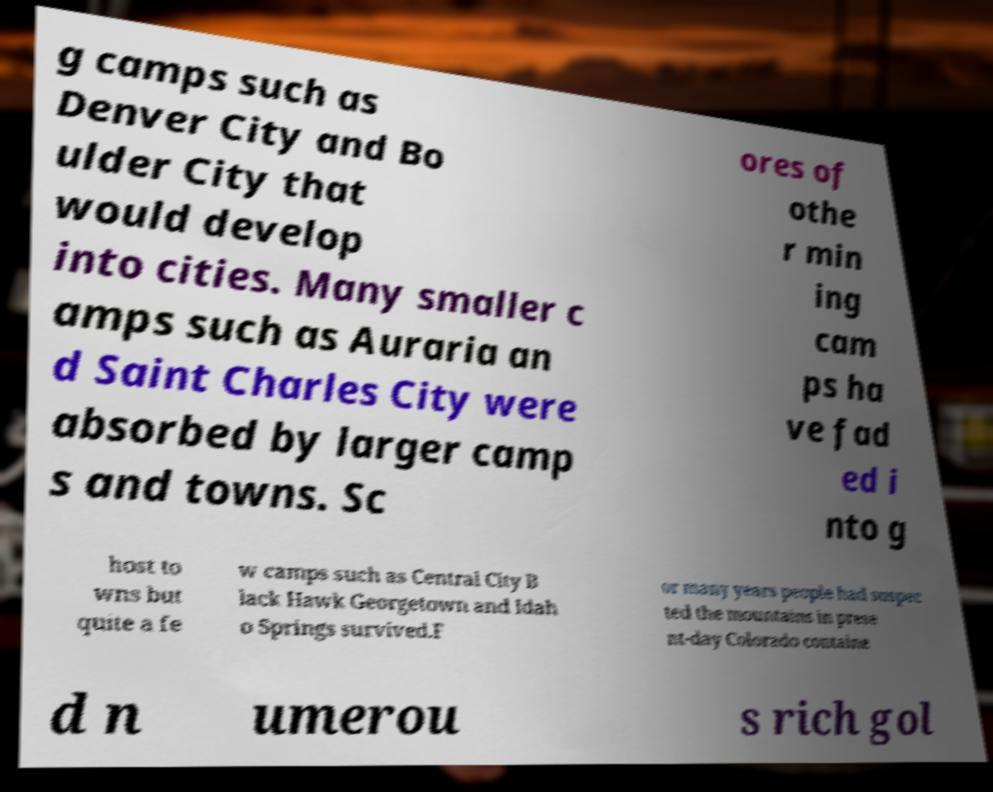Please read and relay the text visible in this image. What does it say? g camps such as Denver City and Bo ulder City that would develop into cities. Many smaller c amps such as Auraria an d Saint Charles City were absorbed by larger camp s and towns. Sc ores of othe r min ing cam ps ha ve fad ed i nto g host to wns but quite a fe w camps such as Central City B lack Hawk Georgetown and Idah o Springs survived.F or many years people had suspec ted the mountains in prese nt-day Colorado containe d n umerou s rich gol 